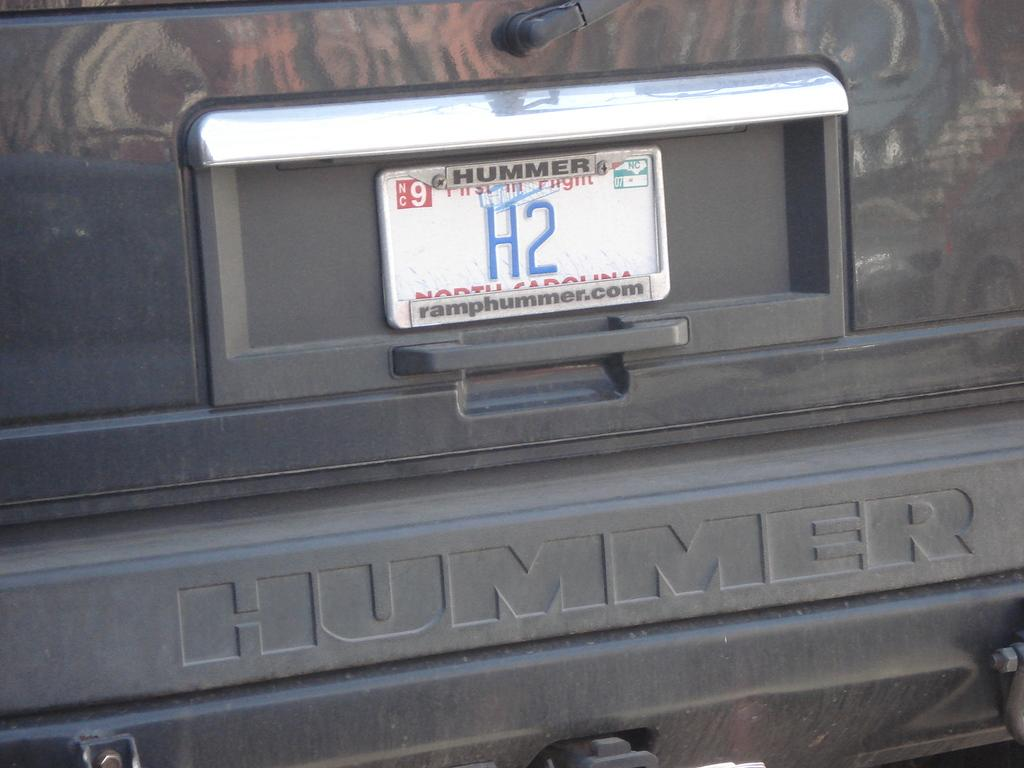Provide a one-sentence caption for the provided image. A North Carolina license plate on a Hummer. 